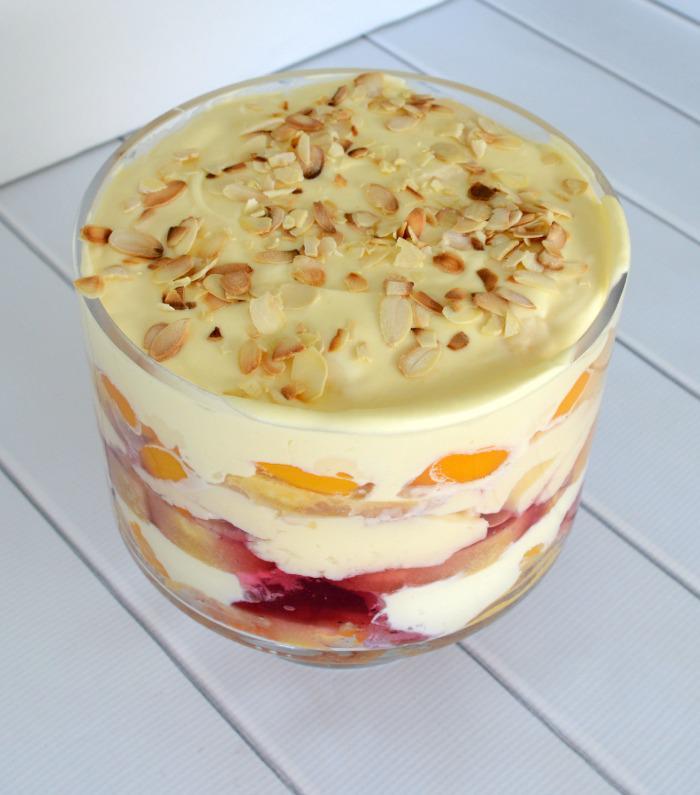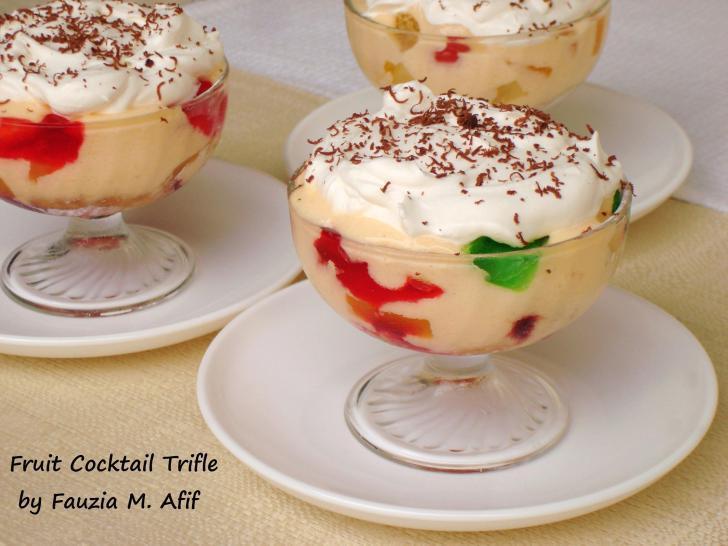The first image is the image on the left, the second image is the image on the right. For the images displayed, is the sentence "An image shows spoons next to a trifle dessert." factually correct? Answer yes or no. No. 